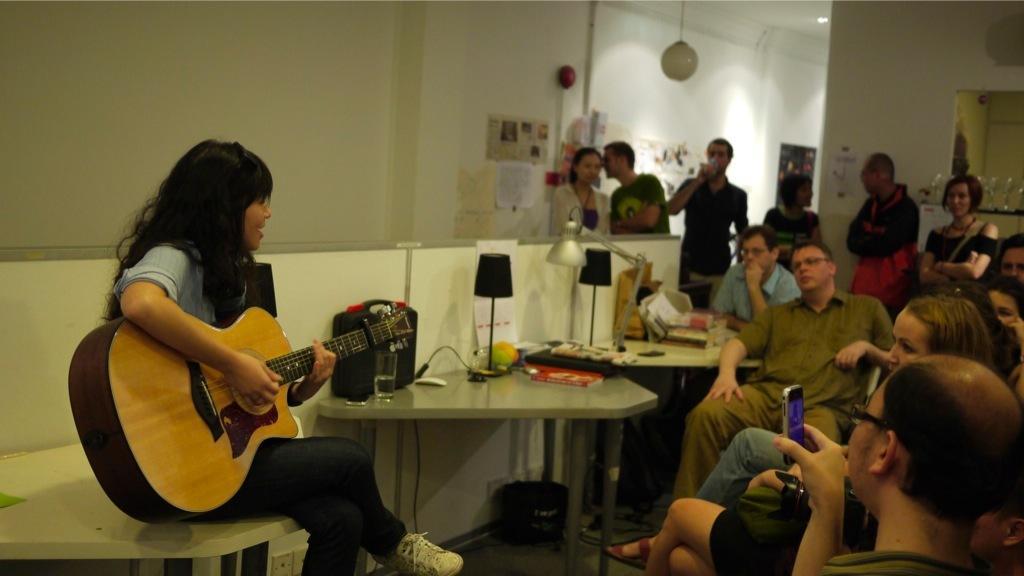Please provide a concise description of this image. a person at the left is playing guitar. people at the right are sitting and listening to him. people at the back are standing 